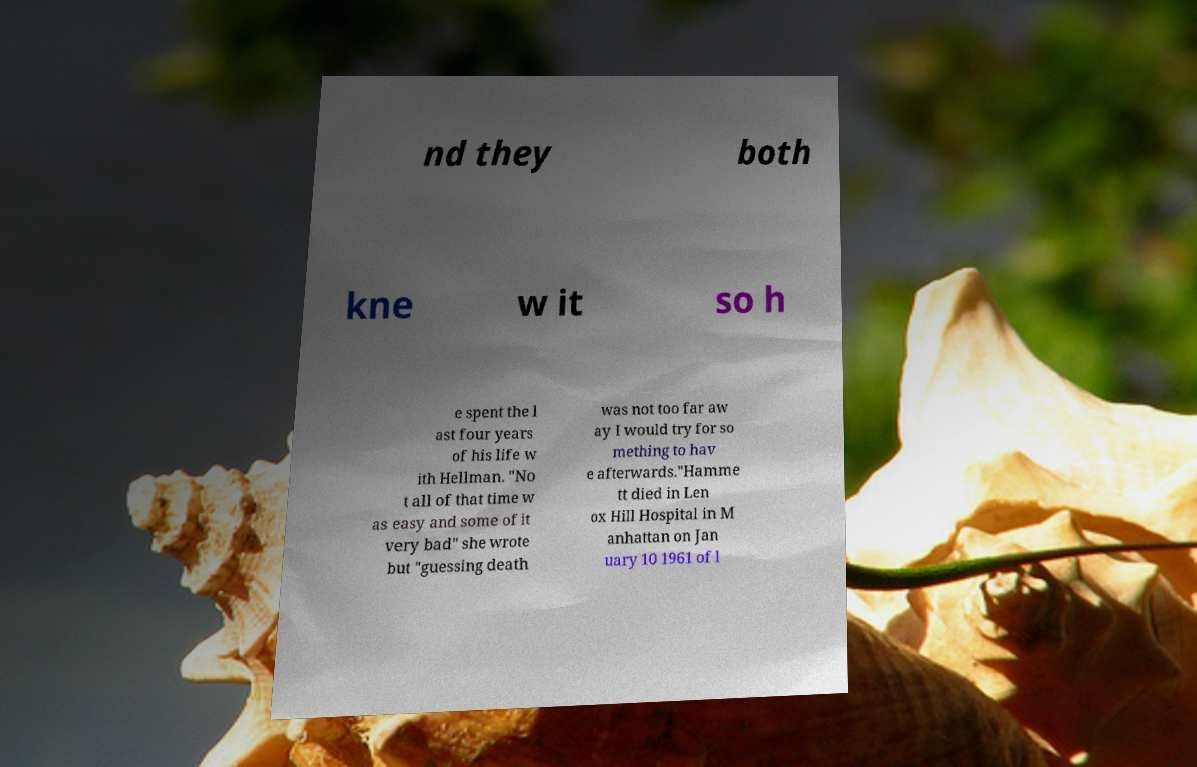Could you extract and type out the text from this image? nd they both kne w it so h e spent the l ast four years of his life w ith Hellman. "No t all of that time w as easy and some of it very bad" she wrote but "guessing death was not too far aw ay I would try for so mething to hav e afterwards."Hamme tt died in Len ox Hill Hospital in M anhattan on Jan uary 10 1961 of l 